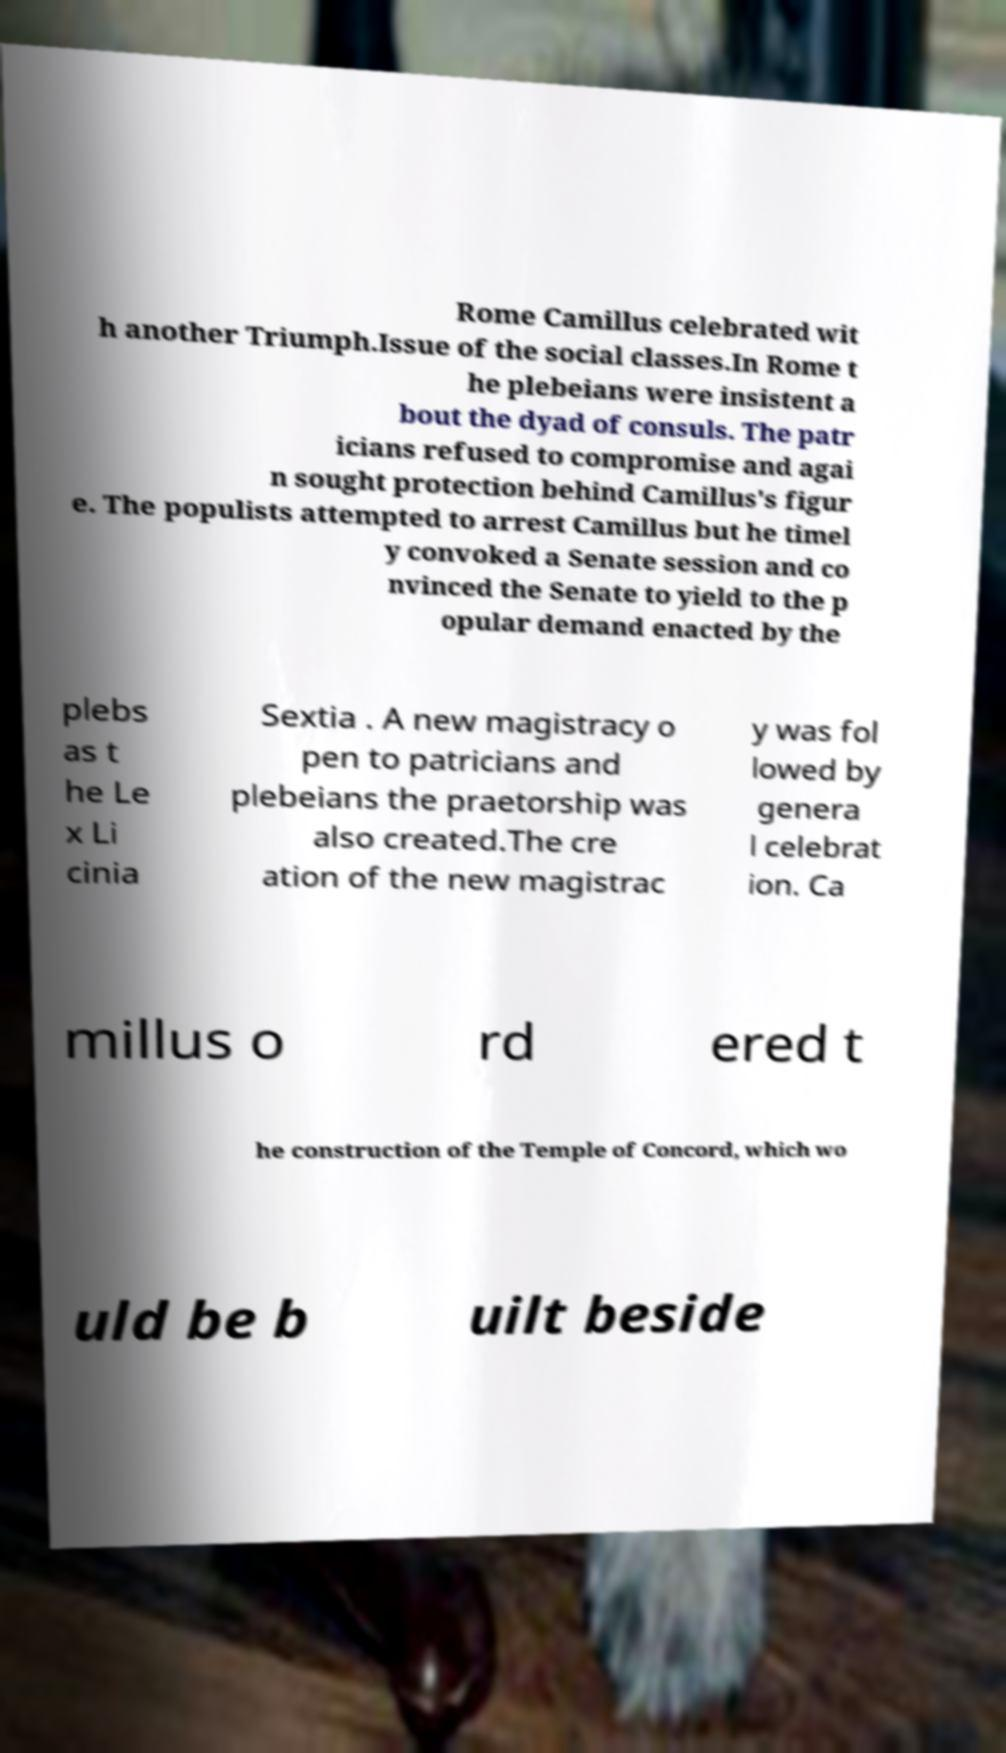There's text embedded in this image that I need extracted. Can you transcribe it verbatim? Rome Camillus celebrated wit h another Triumph.Issue of the social classes.In Rome t he plebeians were insistent a bout the dyad of consuls. The patr icians refused to compromise and agai n sought protection behind Camillus's figur e. The populists attempted to arrest Camillus but he timel y convoked a Senate session and co nvinced the Senate to yield to the p opular demand enacted by the plebs as t he Le x Li cinia Sextia . A new magistracy o pen to patricians and plebeians the praetorship was also created.The cre ation of the new magistrac y was fol lowed by genera l celebrat ion. Ca millus o rd ered t he construction of the Temple of Concord, which wo uld be b uilt beside 